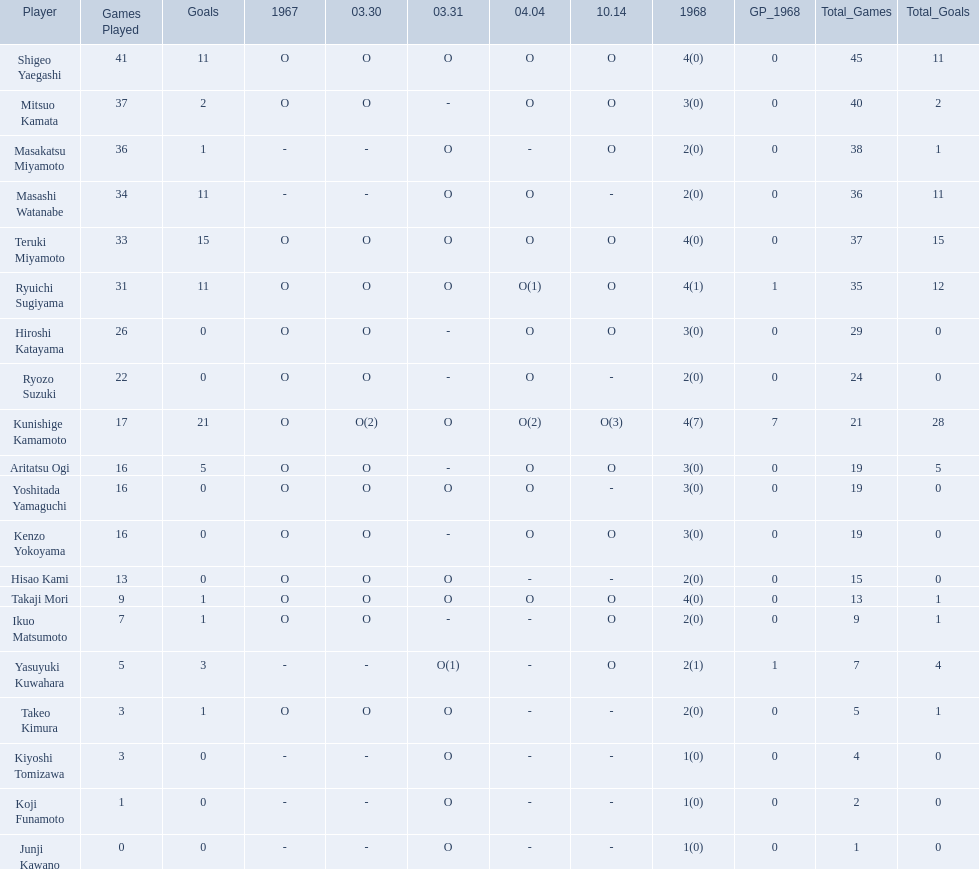Who are all of the players? Shigeo Yaegashi, Mitsuo Kamata, Masakatsu Miyamoto, Masashi Watanabe, Teruki Miyamoto, Ryuichi Sugiyama, Hiroshi Katayama, Ryozo Suzuki, Kunishige Kamamoto, Aritatsu Ogi, Yoshitada Yamaguchi, Kenzo Yokoyama, Hisao Kami, Takaji Mori, Ikuo Matsumoto, Yasuyuki Kuwahara, Takeo Kimura, Kiyoshi Tomizawa, Koji Funamoto, Junji Kawano. How many points did they receive? 45(11), 40(2), 38(1), 36(11), 37(15), 35(12), 29(0), 24(0), 21(28), 19(5), 19(0), 19(0), 15(0), 13(1), 9(1), 7(4), 5(1), 4(0), 2(0), 1(0). What about just takaji mori and junji kawano? 13(1), 1(0). Of the two, who had more points? Takaji Mori. 